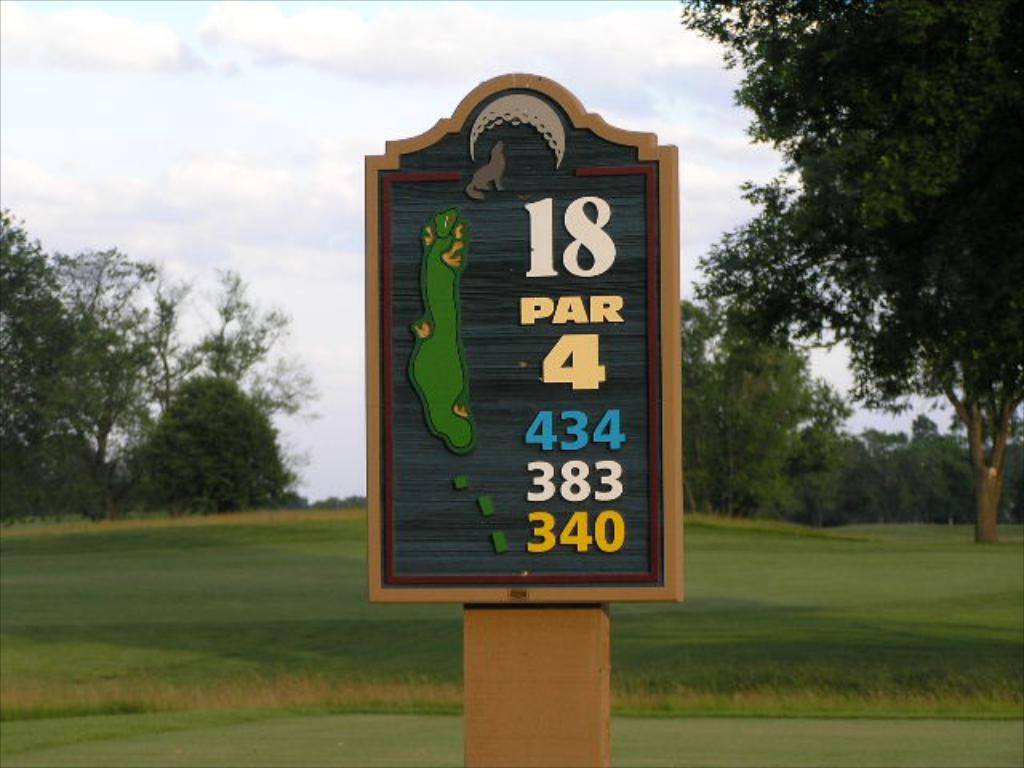<image>
Share a concise interpretation of the image provided. A sign identifies this location as hole 18, a par 4. 